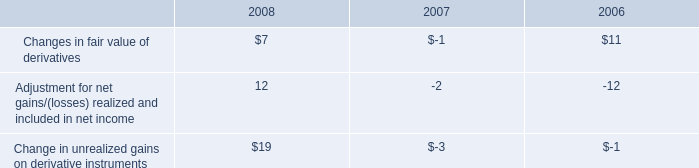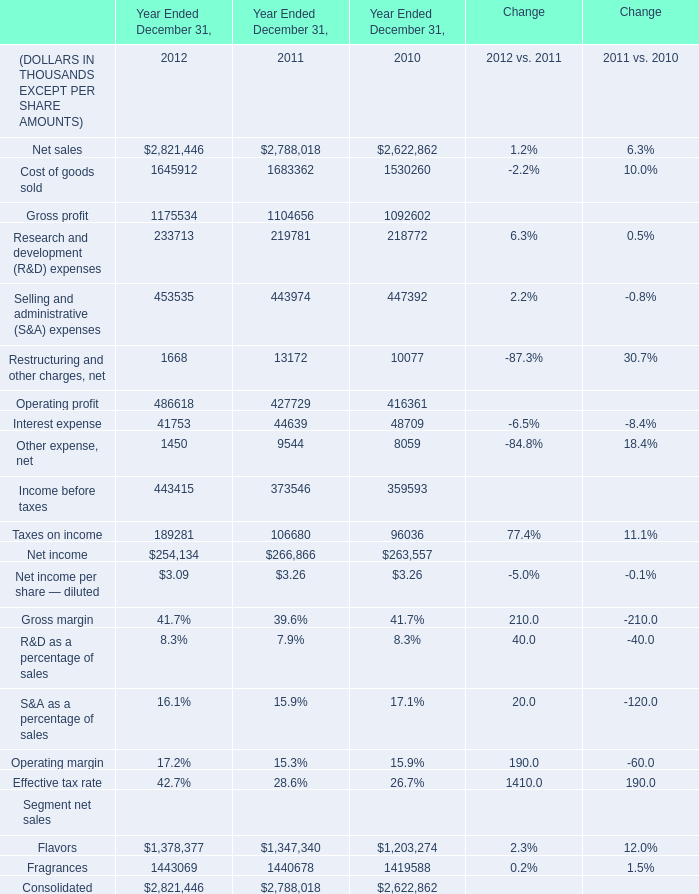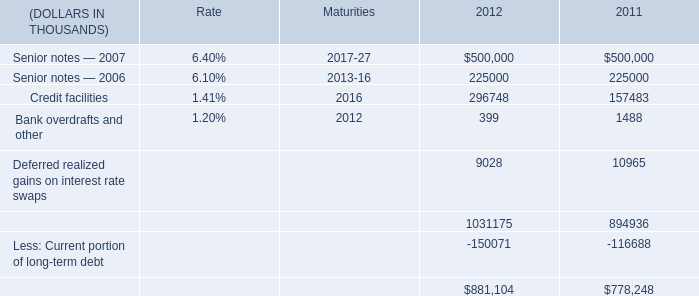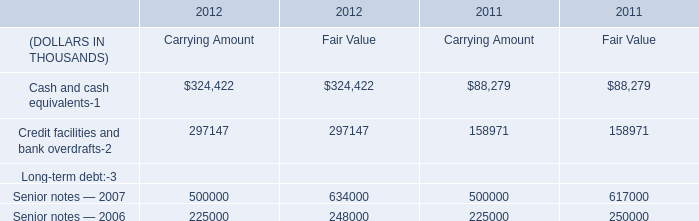What is the total amount of Interest expense of Year Ended December 31, 2010, and Credit facilities and bank overdrafts of 2011 Carrying Amount ? 
Computations: (48709.0 + 158971.0)
Answer: 207680.0. 